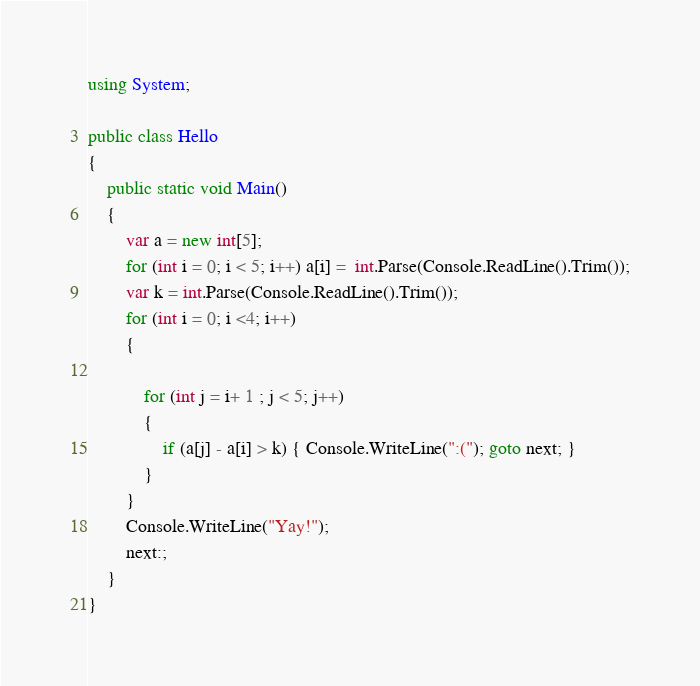Convert code to text. <code><loc_0><loc_0><loc_500><loc_500><_C#_>using System;

public class Hello
{
    public static void Main()
    {
        var a = new int[5];
        for (int i = 0; i < 5; i++) a[i] =  int.Parse(Console.ReadLine().Trim());
        var k = int.Parse(Console.ReadLine().Trim());
        for (int i = 0; i <4; i++)
        {

            for (int j = i+ 1 ; j < 5; j++)
            {
                if (a[j] - a[i] > k) { Console.WriteLine(":("); goto next; }
            }
        }
        Console.WriteLine("Yay!");
        next:;
    }
}</code> 